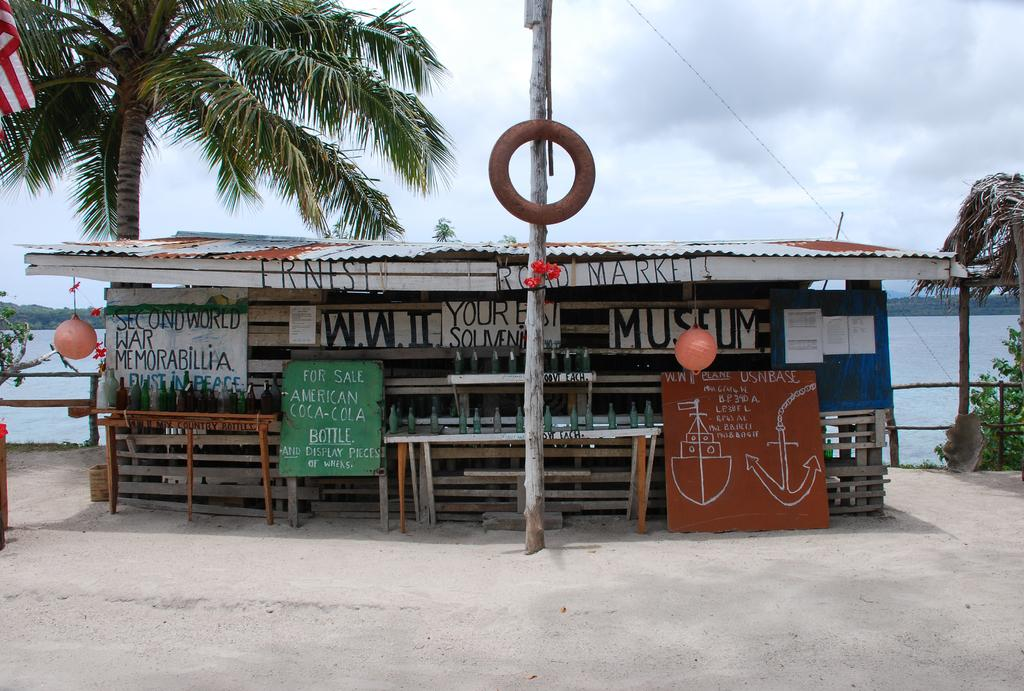What type of structure is present in the image? There is a house in the image. What objects can be seen near the house? There are bottles, notice boards, paper lanterns, and papers visible in the image. What other structures or objects are present in the image? There is a pole, a tube, trees, a flag, and water visible in the image. How many feet are required to carry the crate in the image? There is no crate present in the image, so it is not possible to determine how many feet would be required to carry it. 